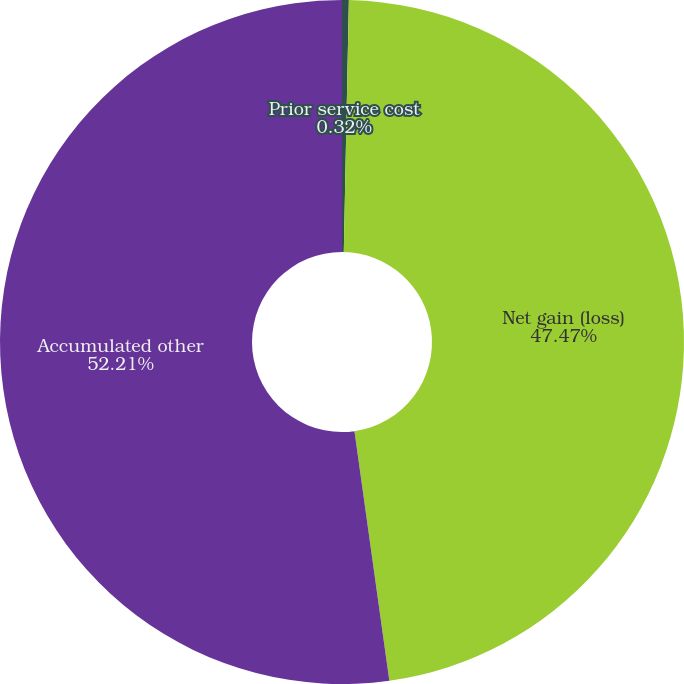<chart> <loc_0><loc_0><loc_500><loc_500><pie_chart><fcel>Prior service cost<fcel>Net gain (loss)<fcel>Accumulated other<nl><fcel>0.32%<fcel>47.47%<fcel>52.21%<nl></chart> 